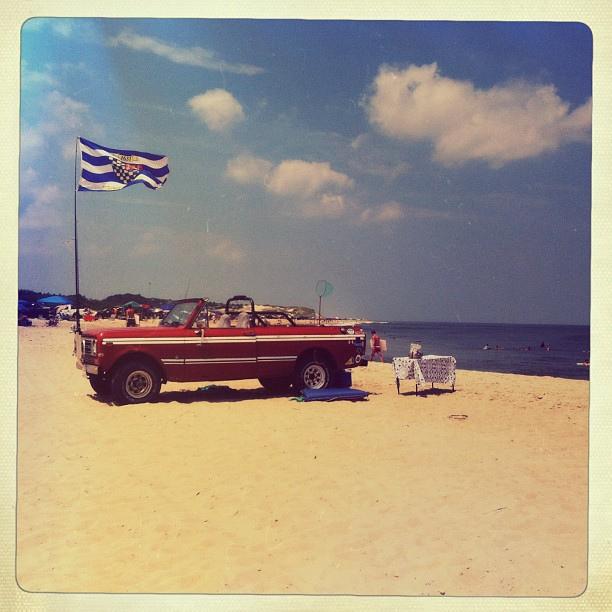What is the symbol on the flag?
Quick response, please. Coat of arms. Is the car parked on the beach?
Keep it brief. Yes. Is the car made in 2014?
Be succinct. No. 